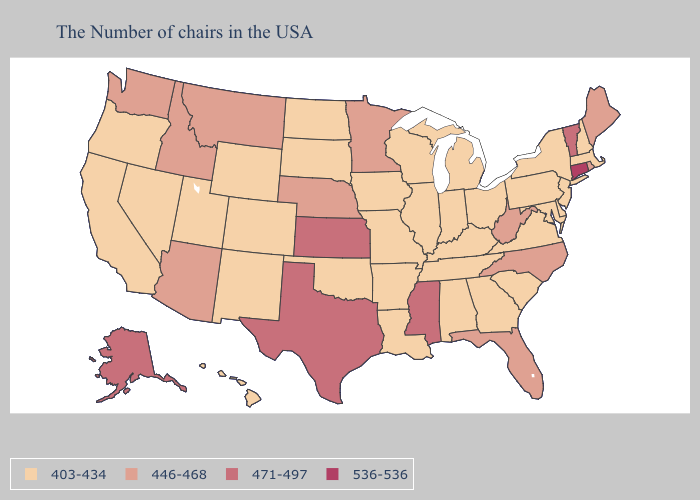Among the states that border Colorado , does New Mexico have the lowest value?
Answer briefly. Yes. Does Connecticut have the lowest value in the Northeast?
Quick response, please. No. What is the value of Hawaii?
Give a very brief answer. 403-434. Which states have the lowest value in the USA?
Concise answer only. Massachusetts, New Hampshire, New York, New Jersey, Delaware, Maryland, Pennsylvania, Virginia, South Carolina, Ohio, Georgia, Michigan, Kentucky, Indiana, Alabama, Tennessee, Wisconsin, Illinois, Louisiana, Missouri, Arkansas, Iowa, Oklahoma, South Dakota, North Dakota, Wyoming, Colorado, New Mexico, Utah, Nevada, California, Oregon, Hawaii. Name the states that have a value in the range 471-497?
Give a very brief answer. Vermont, Mississippi, Kansas, Texas, Alaska. Does Wisconsin have the highest value in the MidWest?
Be succinct. No. What is the lowest value in the USA?
Keep it brief. 403-434. What is the highest value in the USA?
Write a very short answer. 536-536. Is the legend a continuous bar?
Give a very brief answer. No. Does Illinois have the lowest value in the MidWest?
Concise answer only. Yes. What is the value of Louisiana?
Short answer required. 403-434. Name the states that have a value in the range 536-536?
Give a very brief answer. Connecticut. How many symbols are there in the legend?
Write a very short answer. 4. Does the map have missing data?
Short answer required. No. Does Louisiana have the same value as Idaho?
Keep it brief. No. 